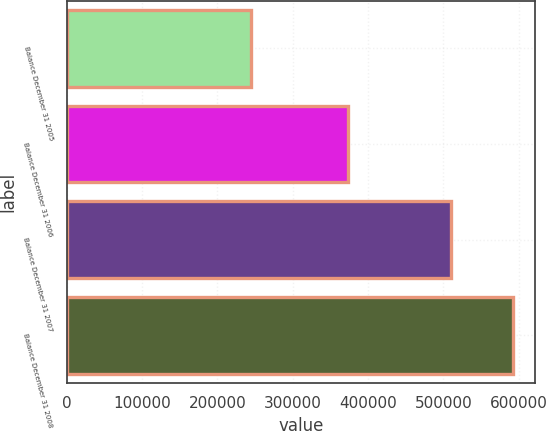<chart> <loc_0><loc_0><loc_500><loc_500><bar_chart><fcel>Balance December 31 2005<fcel>Balance December 31 2006<fcel>Balance December 31 2007<fcel>Balance December 31 2008<nl><fcel>244524<fcel>373387<fcel>509875<fcel>591912<nl></chart> 